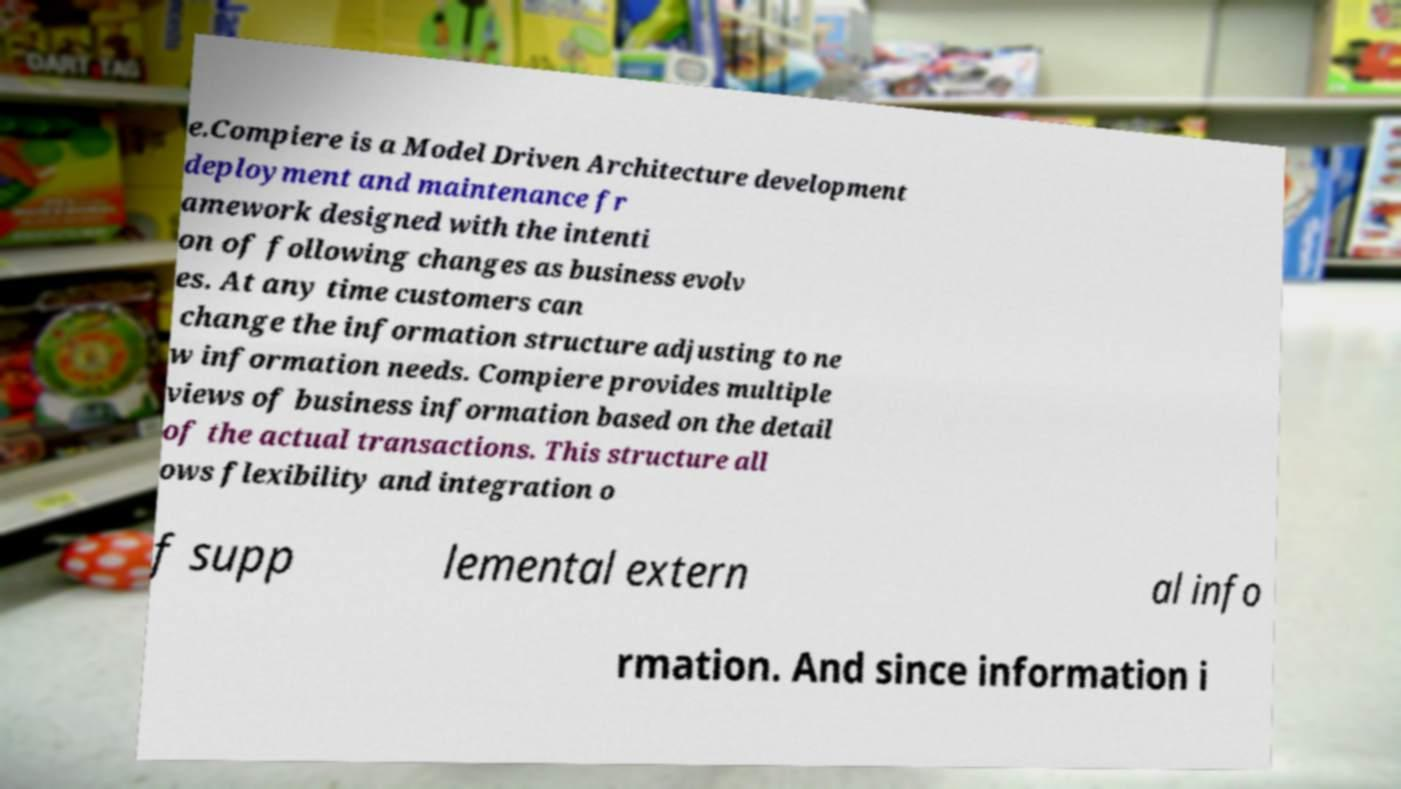Please identify and transcribe the text found in this image. e.Compiere is a Model Driven Architecture development deployment and maintenance fr amework designed with the intenti on of following changes as business evolv es. At any time customers can change the information structure adjusting to ne w information needs. Compiere provides multiple views of business information based on the detail of the actual transactions. This structure all ows flexibility and integration o f supp lemental extern al info rmation. And since information i 